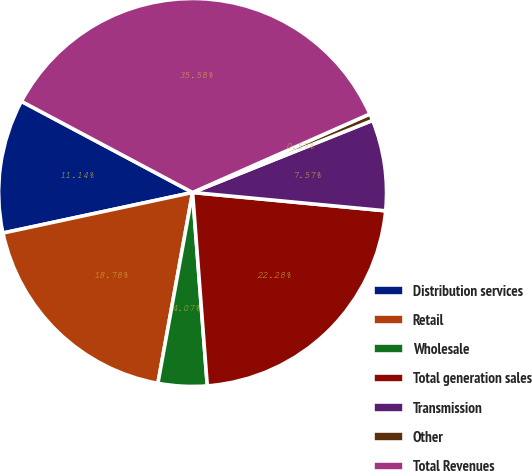Convert chart to OTSL. <chart><loc_0><loc_0><loc_500><loc_500><pie_chart><fcel>Distribution services<fcel>Retail<fcel>Wholesale<fcel>Total generation sales<fcel>Transmission<fcel>Other<fcel>Total Revenues<nl><fcel>11.14%<fcel>18.78%<fcel>4.07%<fcel>22.28%<fcel>7.57%<fcel>0.57%<fcel>35.57%<nl></chart> 